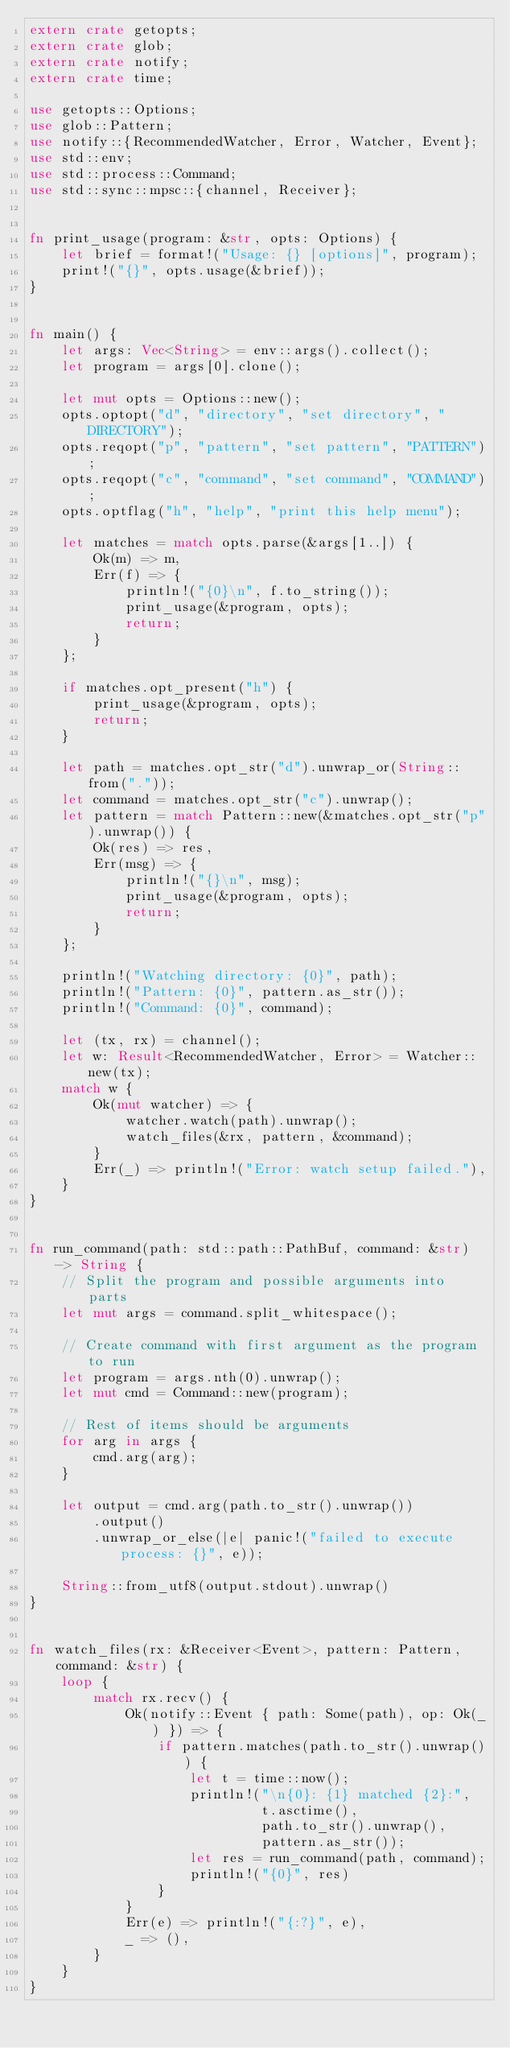<code> <loc_0><loc_0><loc_500><loc_500><_Rust_>extern crate getopts;
extern crate glob;
extern crate notify;
extern crate time;

use getopts::Options;
use glob::Pattern;
use notify::{RecommendedWatcher, Error, Watcher, Event};
use std::env;
use std::process::Command;
use std::sync::mpsc::{channel, Receiver};


fn print_usage(program: &str, opts: Options) {
    let brief = format!("Usage: {} [options]", program);
    print!("{}", opts.usage(&brief));
}


fn main() {
    let args: Vec<String> = env::args().collect();
    let program = args[0].clone();

    let mut opts = Options::new();
    opts.optopt("d", "directory", "set directory", "DIRECTORY");
    opts.reqopt("p", "pattern", "set pattern", "PATTERN");
    opts.reqopt("c", "command", "set command", "COMMAND");
    opts.optflag("h", "help", "print this help menu");

    let matches = match opts.parse(&args[1..]) {
        Ok(m) => m,
        Err(f) => {
            println!("{0}\n", f.to_string());
            print_usage(&program, opts);
            return;
        }
    };

    if matches.opt_present("h") {
        print_usage(&program, opts);
        return;
    }

    let path = matches.opt_str("d").unwrap_or(String::from("."));
    let command = matches.opt_str("c").unwrap();
    let pattern = match Pattern::new(&matches.opt_str("p").unwrap()) {
        Ok(res) => res,
        Err(msg) => {
            println!("{}\n", msg);
            print_usage(&program, opts);
            return;
        }
    };

    println!("Watching directory: {0}", path);
    println!("Pattern: {0}", pattern.as_str());
    println!("Command: {0}", command);

    let (tx, rx) = channel();
    let w: Result<RecommendedWatcher, Error> = Watcher::new(tx);
    match w {
        Ok(mut watcher) => {
            watcher.watch(path).unwrap();
            watch_files(&rx, pattern, &command);
        }
        Err(_) => println!("Error: watch setup failed."),
    }
}


fn run_command(path: std::path::PathBuf, command: &str) -> String {
    // Split the program and possible arguments into parts
    let mut args = command.split_whitespace();

    // Create command with first argument as the program to run
    let program = args.nth(0).unwrap();
    let mut cmd = Command::new(program);

    // Rest of items should be arguments
    for arg in args {
        cmd.arg(arg);
    }

    let output = cmd.arg(path.to_str().unwrap())
        .output()
        .unwrap_or_else(|e| panic!("failed to execute process: {}", e));

    String::from_utf8(output.stdout).unwrap()
}


fn watch_files(rx: &Receiver<Event>, pattern: Pattern, command: &str) {
    loop {
        match rx.recv() {
            Ok(notify::Event { path: Some(path), op: Ok(_) }) => {
                if pattern.matches(path.to_str().unwrap()) {
                    let t = time::now();
                    println!("\n{0}: {1} matched {2}:",
                             t.asctime(),
                             path.to_str().unwrap(),
                             pattern.as_str());
                    let res = run_command(path, command);
                    println!("{0}", res)
                }
            }
            Err(e) => println!("{:?}", e),
            _ => (),
        }
    }
}
</code> 